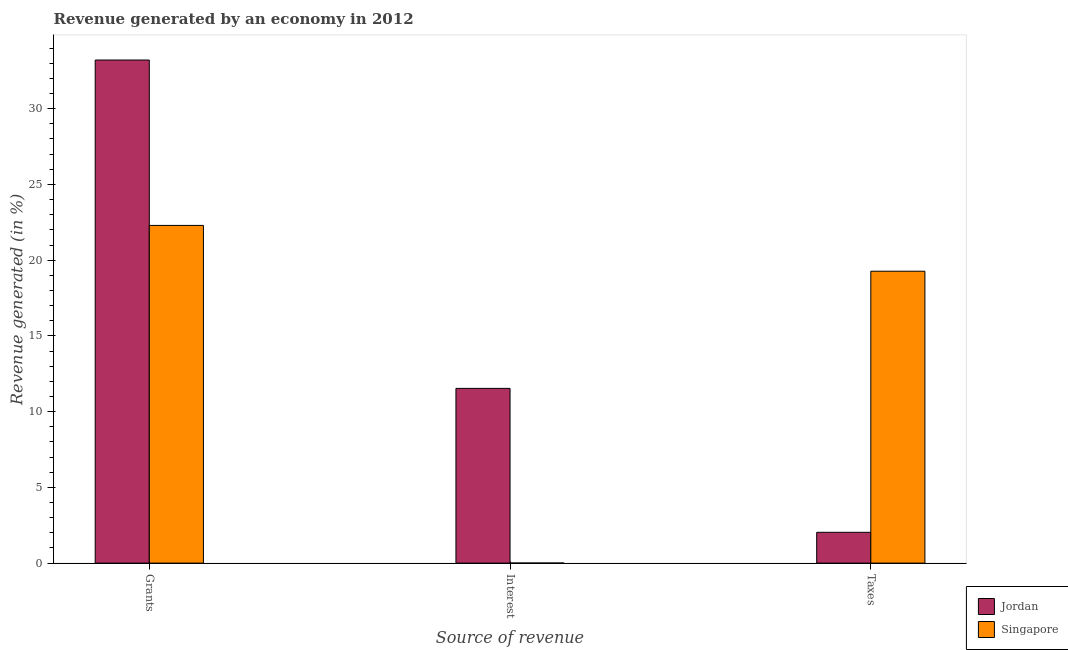How many bars are there on the 2nd tick from the left?
Your response must be concise. 2. How many bars are there on the 2nd tick from the right?
Offer a very short reply. 2. What is the label of the 2nd group of bars from the left?
Offer a very short reply. Interest. What is the percentage of revenue generated by interest in Singapore?
Ensure brevity in your answer.  0. Across all countries, what is the maximum percentage of revenue generated by interest?
Your answer should be very brief. 11.53. Across all countries, what is the minimum percentage of revenue generated by grants?
Your answer should be very brief. 22.29. In which country was the percentage of revenue generated by taxes maximum?
Offer a very short reply. Singapore. In which country was the percentage of revenue generated by taxes minimum?
Ensure brevity in your answer.  Jordan. What is the total percentage of revenue generated by interest in the graph?
Offer a terse response. 11.54. What is the difference between the percentage of revenue generated by taxes in Jordan and that in Singapore?
Offer a terse response. -17.24. What is the difference between the percentage of revenue generated by taxes in Jordan and the percentage of revenue generated by interest in Singapore?
Offer a terse response. 2.03. What is the average percentage of revenue generated by taxes per country?
Your answer should be very brief. 10.65. What is the difference between the percentage of revenue generated by taxes and percentage of revenue generated by interest in Singapore?
Your answer should be compact. 19.27. What is the ratio of the percentage of revenue generated by interest in Jordan to that in Singapore?
Your answer should be very brief. 2323.14. Is the difference between the percentage of revenue generated by grants in Singapore and Jordan greater than the difference between the percentage of revenue generated by taxes in Singapore and Jordan?
Your response must be concise. No. What is the difference between the highest and the second highest percentage of revenue generated by interest?
Keep it short and to the point. 11.53. What is the difference between the highest and the lowest percentage of revenue generated by grants?
Provide a short and direct response. 10.92. Is the sum of the percentage of revenue generated by grants in Jordan and Singapore greater than the maximum percentage of revenue generated by interest across all countries?
Make the answer very short. Yes. What does the 1st bar from the left in Grants represents?
Offer a very short reply. Jordan. What does the 1st bar from the right in Grants represents?
Keep it short and to the point. Singapore. How many countries are there in the graph?
Ensure brevity in your answer.  2. Does the graph contain any zero values?
Your answer should be very brief. No. Does the graph contain grids?
Offer a very short reply. No. How many legend labels are there?
Your response must be concise. 2. What is the title of the graph?
Offer a very short reply. Revenue generated by an economy in 2012. What is the label or title of the X-axis?
Your answer should be compact. Source of revenue. What is the label or title of the Y-axis?
Keep it short and to the point. Revenue generated (in %). What is the Revenue generated (in %) of Jordan in Grants?
Offer a terse response. 33.21. What is the Revenue generated (in %) of Singapore in Grants?
Give a very brief answer. 22.29. What is the Revenue generated (in %) of Jordan in Interest?
Provide a short and direct response. 11.53. What is the Revenue generated (in %) of Singapore in Interest?
Your answer should be compact. 0. What is the Revenue generated (in %) in Jordan in Taxes?
Your answer should be compact. 2.03. What is the Revenue generated (in %) of Singapore in Taxes?
Offer a very short reply. 19.27. Across all Source of revenue, what is the maximum Revenue generated (in %) of Jordan?
Your response must be concise. 33.21. Across all Source of revenue, what is the maximum Revenue generated (in %) in Singapore?
Keep it short and to the point. 22.29. Across all Source of revenue, what is the minimum Revenue generated (in %) of Jordan?
Offer a terse response. 2.03. Across all Source of revenue, what is the minimum Revenue generated (in %) in Singapore?
Offer a very short reply. 0. What is the total Revenue generated (in %) in Jordan in the graph?
Provide a succinct answer. 46.78. What is the total Revenue generated (in %) in Singapore in the graph?
Make the answer very short. 41.57. What is the difference between the Revenue generated (in %) of Jordan in Grants and that in Interest?
Your answer should be compact. 21.68. What is the difference between the Revenue generated (in %) in Singapore in Grants and that in Interest?
Ensure brevity in your answer.  22.29. What is the difference between the Revenue generated (in %) in Jordan in Grants and that in Taxes?
Your response must be concise. 31.18. What is the difference between the Revenue generated (in %) in Singapore in Grants and that in Taxes?
Ensure brevity in your answer.  3.02. What is the difference between the Revenue generated (in %) in Jordan in Interest and that in Taxes?
Provide a short and direct response. 9.5. What is the difference between the Revenue generated (in %) of Singapore in Interest and that in Taxes?
Provide a succinct answer. -19.27. What is the difference between the Revenue generated (in %) of Jordan in Grants and the Revenue generated (in %) of Singapore in Interest?
Provide a succinct answer. 33.21. What is the difference between the Revenue generated (in %) in Jordan in Grants and the Revenue generated (in %) in Singapore in Taxes?
Provide a short and direct response. 13.94. What is the difference between the Revenue generated (in %) in Jordan in Interest and the Revenue generated (in %) in Singapore in Taxes?
Offer a terse response. -7.74. What is the average Revenue generated (in %) in Jordan per Source of revenue?
Ensure brevity in your answer.  15.59. What is the average Revenue generated (in %) of Singapore per Source of revenue?
Provide a short and direct response. 13.86. What is the difference between the Revenue generated (in %) of Jordan and Revenue generated (in %) of Singapore in Grants?
Provide a short and direct response. 10.92. What is the difference between the Revenue generated (in %) in Jordan and Revenue generated (in %) in Singapore in Interest?
Give a very brief answer. 11.53. What is the difference between the Revenue generated (in %) in Jordan and Revenue generated (in %) in Singapore in Taxes?
Keep it short and to the point. -17.24. What is the ratio of the Revenue generated (in %) in Jordan in Grants to that in Interest?
Offer a very short reply. 2.88. What is the ratio of the Revenue generated (in %) of Singapore in Grants to that in Interest?
Offer a terse response. 4489.94. What is the ratio of the Revenue generated (in %) in Jordan in Grants to that in Taxes?
Offer a very short reply. 16.33. What is the ratio of the Revenue generated (in %) of Singapore in Grants to that in Taxes?
Your response must be concise. 1.16. What is the ratio of the Revenue generated (in %) in Jordan in Interest to that in Taxes?
Make the answer very short. 5.67. What is the difference between the highest and the second highest Revenue generated (in %) in Jordan?
Ensure brevity in your answer.  21.68. What is the difference between the highest and the second highest Revenue generated (in %) in Singapore?
Ensure brevity in your answer.  3.02. What is the difference between the highest and the lowest Revenue generated (in %) of Jordan?
Provide a succinct answer. 31.18. What is the difference between the highest and the lowest Revenue generated (in %) in Singapore?
Make the answer very short. 22.29. 